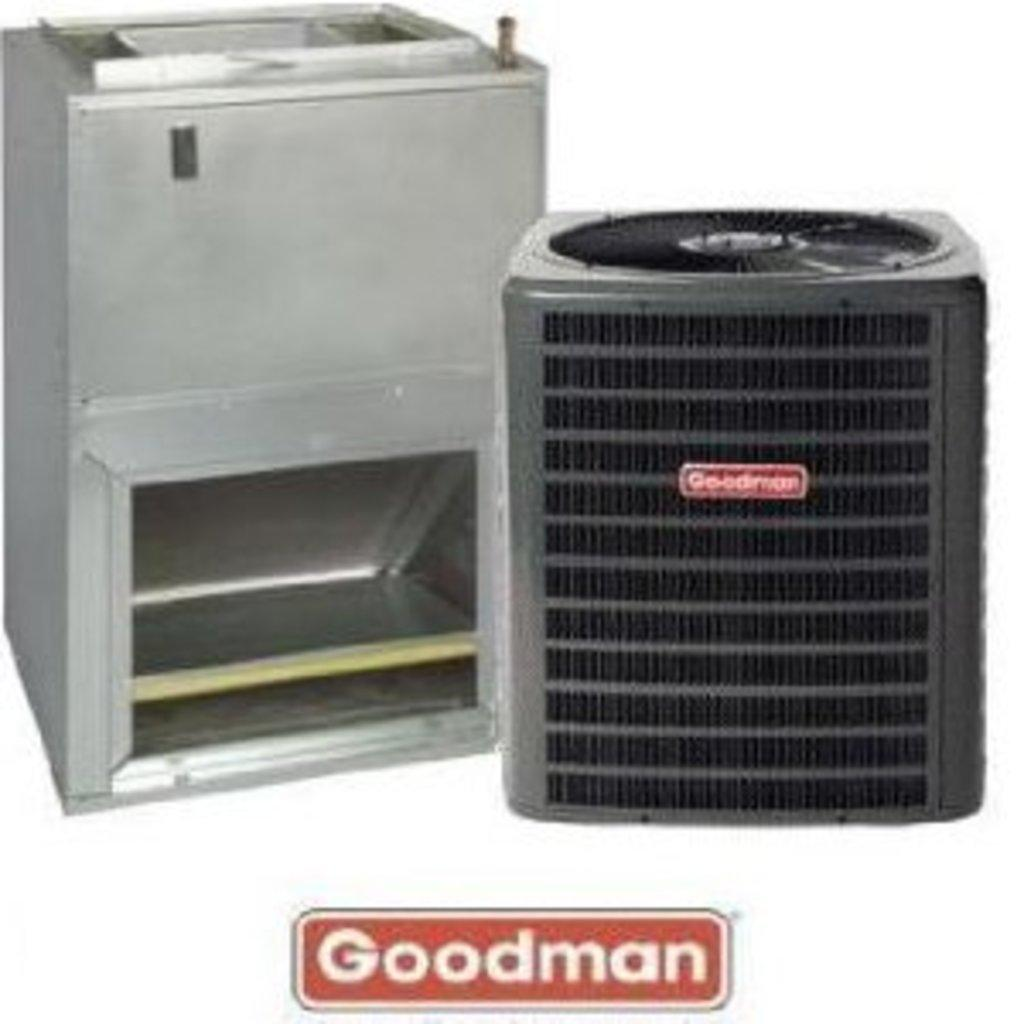Provide a one-sentence caption for the provided image. A brand new goodman central air conditioner unit. 